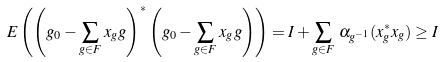<formula> <loc_0><loc_0><loc_500><loc_500>E \left ( \left ( g _ { 0 } - { \sum _ { g \in F } } \, x _ { g } g \right ) ^ { * } \left ( g _ { 0 } - { \sum _ { g \in F } } \, x _ { g } g \right ) \right ) = I + { \sum _ { g \in F } \, \alpha _ { g ^ { - 1 } } ( x _ { g } ^ { * } x _ { g } ) } \geq I</formula> 